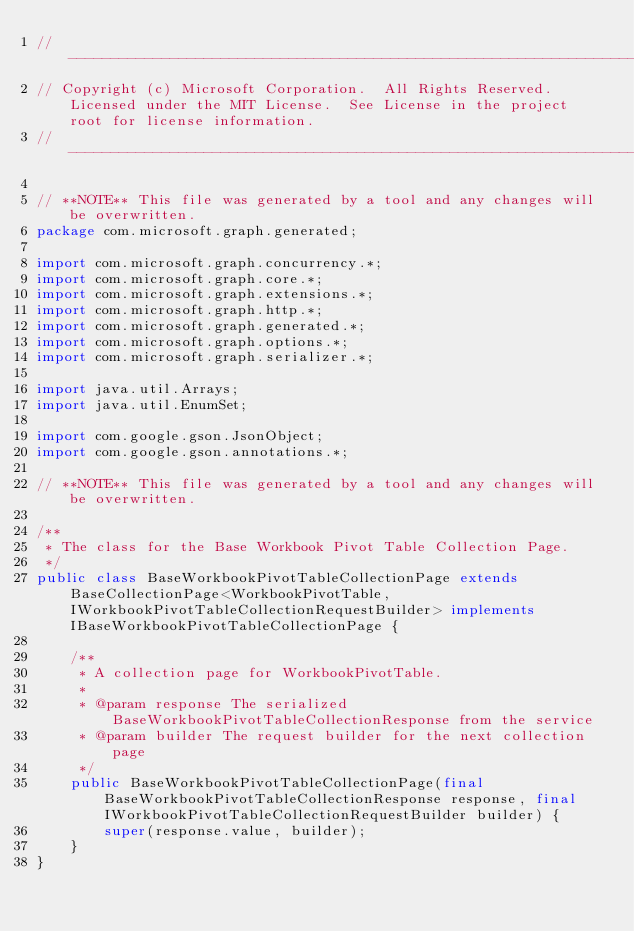Convert code to text. <code><loc_0><loc_0><loc_500><loc_500><_Java_>// ------------------------------------------------------------------------------
// Copyright (c) Microsoft Corporation.  All Rights Reserved.  Licensed under the MIT License.  See License in the project root for license information.
// ------------------------------------------------------------------------------

// **NOTE** This file was generated by a tool and any changes will be overwritten.
package com.microsoft.graph.generated;

import com.microsoft.graph.concurrency.*;
import com.microsoft.graph.core.*;
import com.microsoft.graph.extensions.*;
import com.microsoft.graph.http.*;
import com.microsoft.graph.generated.*;
import com.microsoft.graph.options.*;
import com.microsoft.graph.serializer.*;

import java.util.Arrays;
import java.util.EnumSet;

import com.google.gson.JsonObject;
import com.google.gson.annotations.*;

// **NOTE** This file was generated by a tool and any changes will be overwritten.

/**
 * The class for the Base Workbook Pivot Table Collection Page.
 */
public class BaseWorkbookPivotTableCollectionPage extends BaseCollectionPage<WorkbookPivotTable, IWorkbookPivotTableCollectionRequestBuilder> implements IBaseWorkbookPivotTableCollectionPage {

    /**
     * A collection page for WorkbookPivotTable.
     *
     * @param response The serialized BaseWorkbookPivotTableCollectionResponse from the service
     * @param builder The request builder for the next collection page
     */
    public BaseWorkbookPivotTableCollectionPage(final BaseWorkbookPivotTableCollectionResponse response, final IWorkbookPivotTableCollectionRequestBuilder builder) {
        super(response.value, builder);
    }
}
</code> 